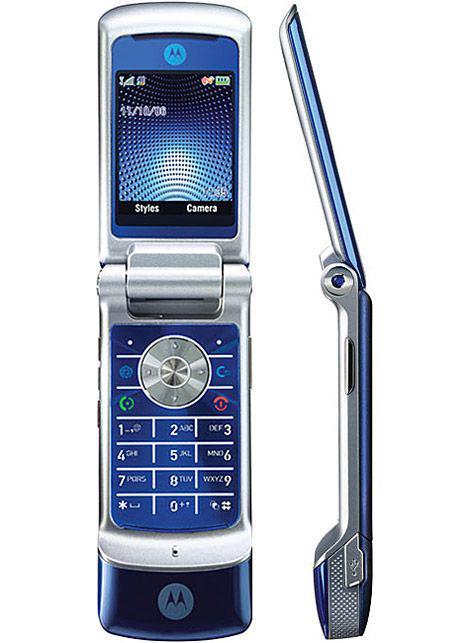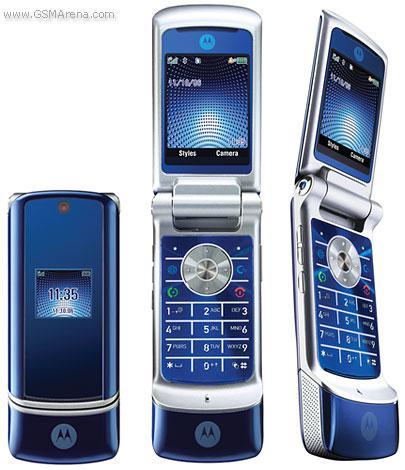The first image is the image on the left, the second image is the image on the right. For the images displayed, is the sentence "There are at least three phones side by side in one of the pictures." factually correct? Answer yes or no. Yes. The first image is the image on the left, the second image is the image on the right. Evaluate the accuracy of this statement regarding the images: "The left image contains one diagonally-displayed black phone with a picture on its screen and its front slid partly up to reveal its keypad.". Is it true? Answer yes or no. No. 